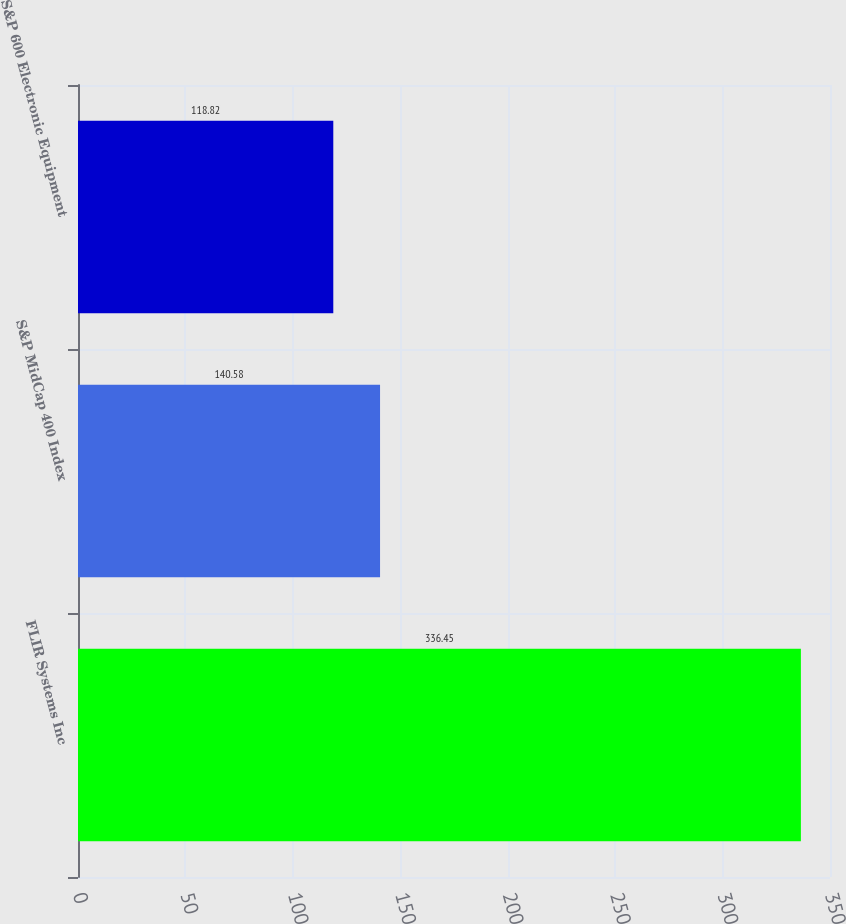Convert chart to OTSL. <chart><loc_0><loc_0><loc_500><loc_500><bar_chart><fcel>FLIR Systems Inc<fcel>S&P MidCap 400 Index<fcel>S&P 600 Electronic Equipment<nl><fcel>336.45<fcel>140.58<fcel>118.82<nl></chart> 